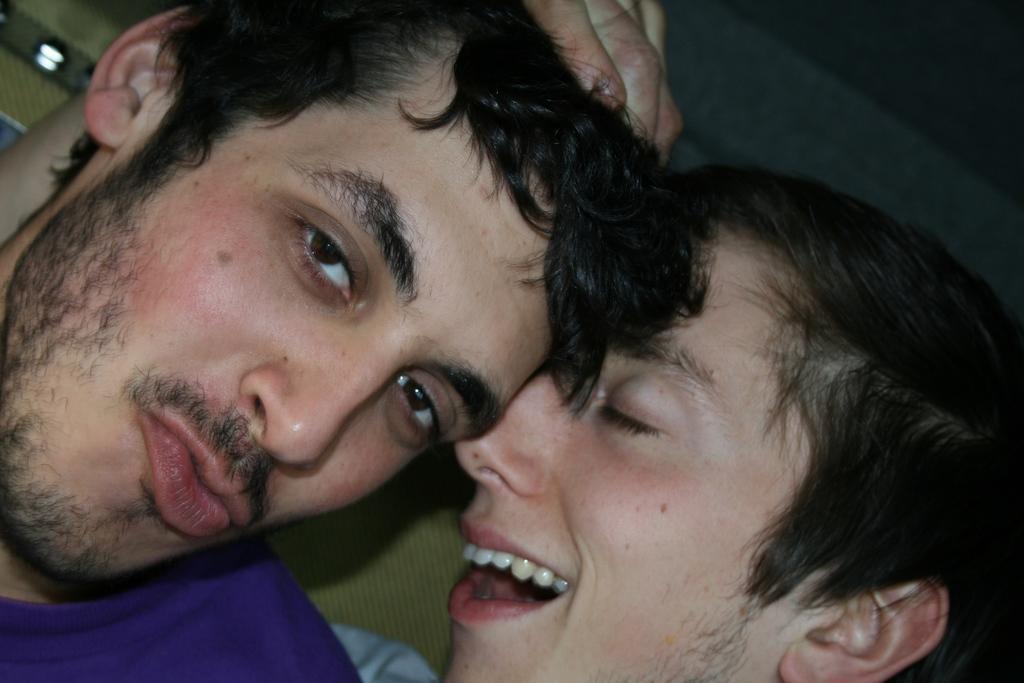Describe this image in one or two sentences. In this picture we can see few people, in the background we can find few lights. 